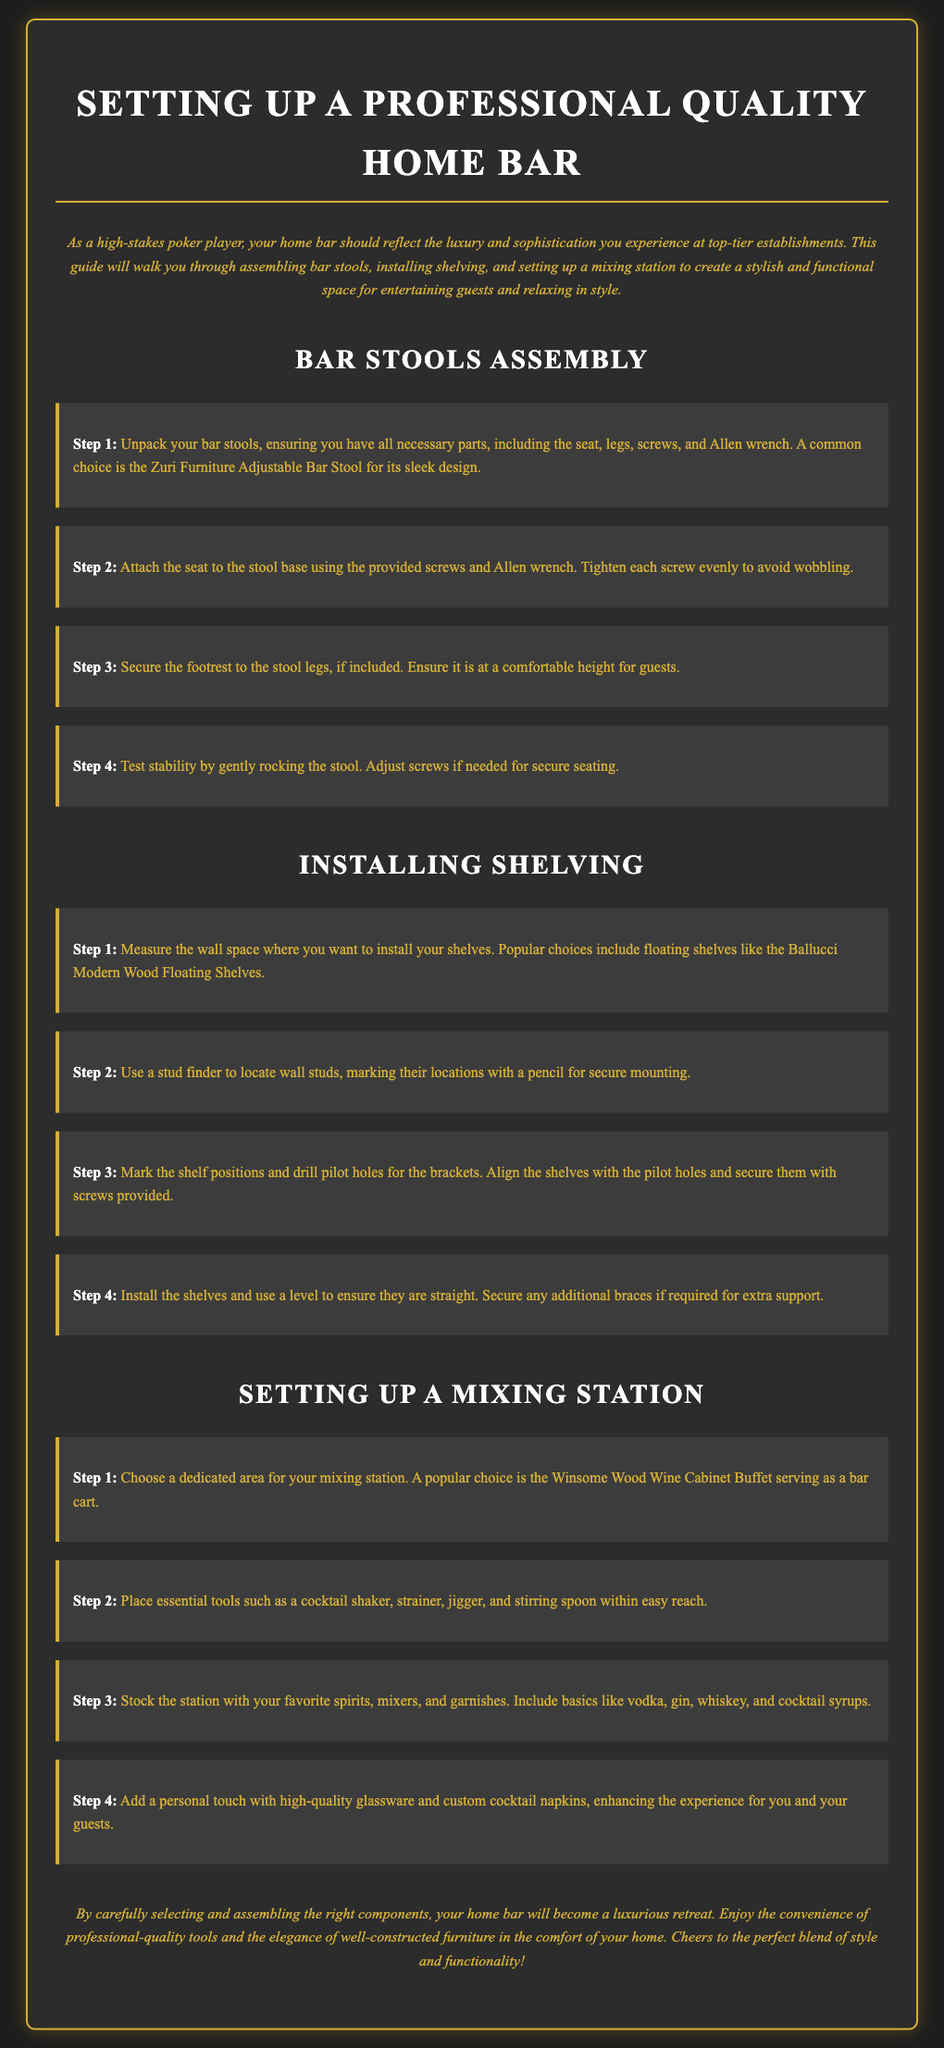What is the main purpose of the guide? The introduction states that the guide is for assembling bar stools, installing shelving, and setting up a mixing station for a home bar.
Answer: Creating a stylish and functional space How many steps are there in the bar stools assembly? The document outlines 4 steps in the bar stool assembly section.
Answer: Four steps What tool is recommended for securing the bar stool seat? The instructional sections specify the use of an Allen wrench for attaching the seat.
Answer: Allen wrench What type of shelves is suggested for installation? The document mentions floating shelves, particularly the Ballucci Modern Wood Floating Shelves, as a popular choice.
Answer: Floating shelves Which item is recommended for a mixing station? The guide suggests using the Winsome Wood Wine Cabinet Buffet for the mixing station.
Answer: Winsome Wood Wine Cabinet Buffet What should you check after installing the shelves? The instructions advise using a level to ensure the shelves are straight after installation.
Answer: Use a level What essential tools should be within easy reach at the mixing station? The document lists essential tools including a cocktail shaker, strainer, jigger, and stirring spoon.
Answer: Cocktail shaker, strainer, jigger, stirring spoon What type of experience is aimed for in the home bar setup? The conclusion suggests that the home bar should provide a luxurious retreat and the convenience of professional-quality tools.
Answer: Luxurious retreat 